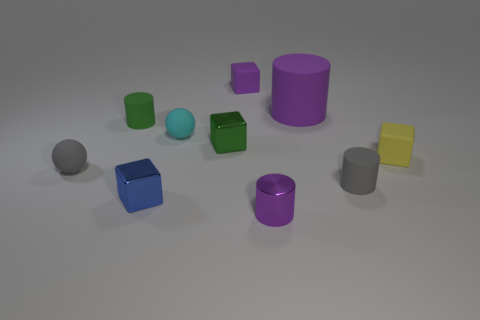Are there any other things that have the same size as the purple rubber cylinder?
Provide a short and direct response. No. What shape is the large rubber thing that is the same color as the metallic cylinder?
Offer a terse response. Cylinder. What material is the ball that is behind the yellow matte object that is on the right side of the matte cylinder that is on the left side of the cyan matte sphere made of?
Ensure brevity in your answer.  Rubber. Does the tiny metallic object that is behind the yellow rubber thing have the same shape as the blue object?
Your response must be concise. Yes. There is a tiny purple object behind the tiny yellow rubber thing; what is it made of?
Provide a succinct answer. Rubber. What number of rubber objects are red balls or purple cylinders?
Keep it short and to the point. 1. Are there any other gray balls of the same size as the gray matte sphere?
Give a very brief answer. No. Are there more purple matte things behind the tiny purple rubber object than big green matte cylinders?
Give a very brief answer. No. How many small things are green objects or green matte things?
Offer a very short reply. 2. What number of other purple things have the same shape as the big matte thing?
Provide a short and direct response. 1. 